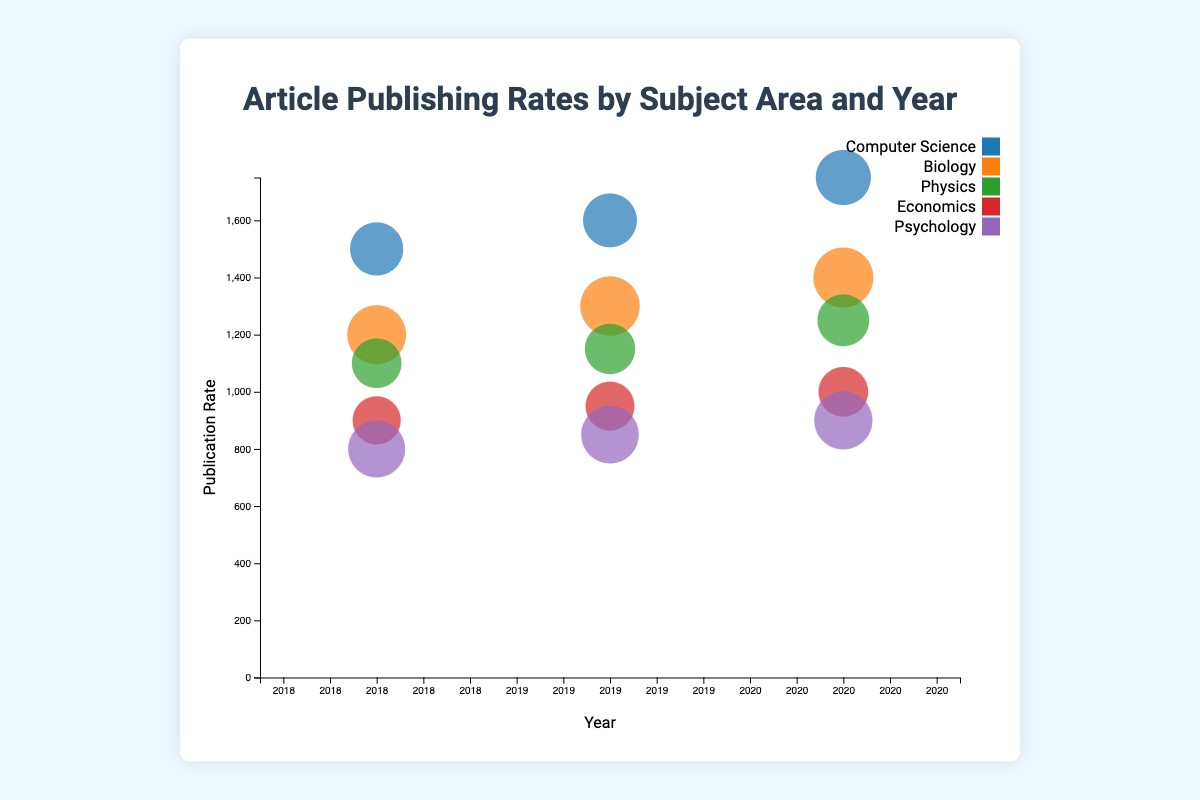How many subject areas are represented in the chart? There are five subject areas in the chart. They can be identified by different colors used for the bubbles and their labels in the legend: Computer Science, Biology, Physics, Economics, and Psychology.
Answer: 5 Which subject area had the highest publication rate in 2020? To find the subject area with the highest publication rate in 2020, look at the year 2020 on the x-axis and identify which bubble is the highest on the y-axis. The bubble corresponding to Computer Science has the highest publication rate in 2020.
Answer: Computer Science What is the general trend in publication rates for Computer Science from 2018 to 2020? To determine the trend, observe the position of bubbles for Computer Science across the years 2018, 2019, and 2020 on the x-axis. The bubbles move upwards in the y-axis, indicating increasing publication rates.
Answer: Increasing Which subject area had the lowest impact factor across all years? To find the subject with the lowest impact factor, you need to look at the size of the bubbles (smaller bubbles indicate lower impact factors). Among all bubbles, those for Economics are consistently smaller, indicating it had the lowest impact factor.
Answer: Economics By how much did the publication rate for Biology increase from 2018 to 2020? To find the increase, note the publication rates for Biology in 2018 and 2020 (1200 and 1400, respectively) and subtract the earlier rate from the later rate: 1400 - 1200 = 200.
Answer: 200 Which year had the highest total publication rate across all subject areas? To determine this, sum the publication rates for all subject areas in each year and compare the totals. The totals are 5500 (2018), 5850 (2019), and 6050 (2020). 2020 has the highest total publication rate.
Answer: 2020 Was there a subject area that saw a consistent increase in impact factor from 2018 to 2020? To check for a consistent increase in impact factor, look at the sizes of the bubbles for each subject area across the years. Biology shows a consistent increase in bubble size from 4.1 in 2018 to 4.3 in 2020.
Answer: Biology How does the publication rate for Psychology in 2019 compare to its publication rate in 2018 and 2020? Check the y-position of the Psychology bubbles in 2018, 2019, and 2020. The publication rate increases from 800 in 2018 to 850 in 2019 and further to 900 in 2020, showing a steady increase.
Answer: Increased in both years Which subject area had the highest impact factor in any year? To identify the highest impact factor, look for the largest bubble across all years. The largest bubble corresponds to Biology in 2020, with an impact factor of 4.3.
Answer: Biology (2020) 